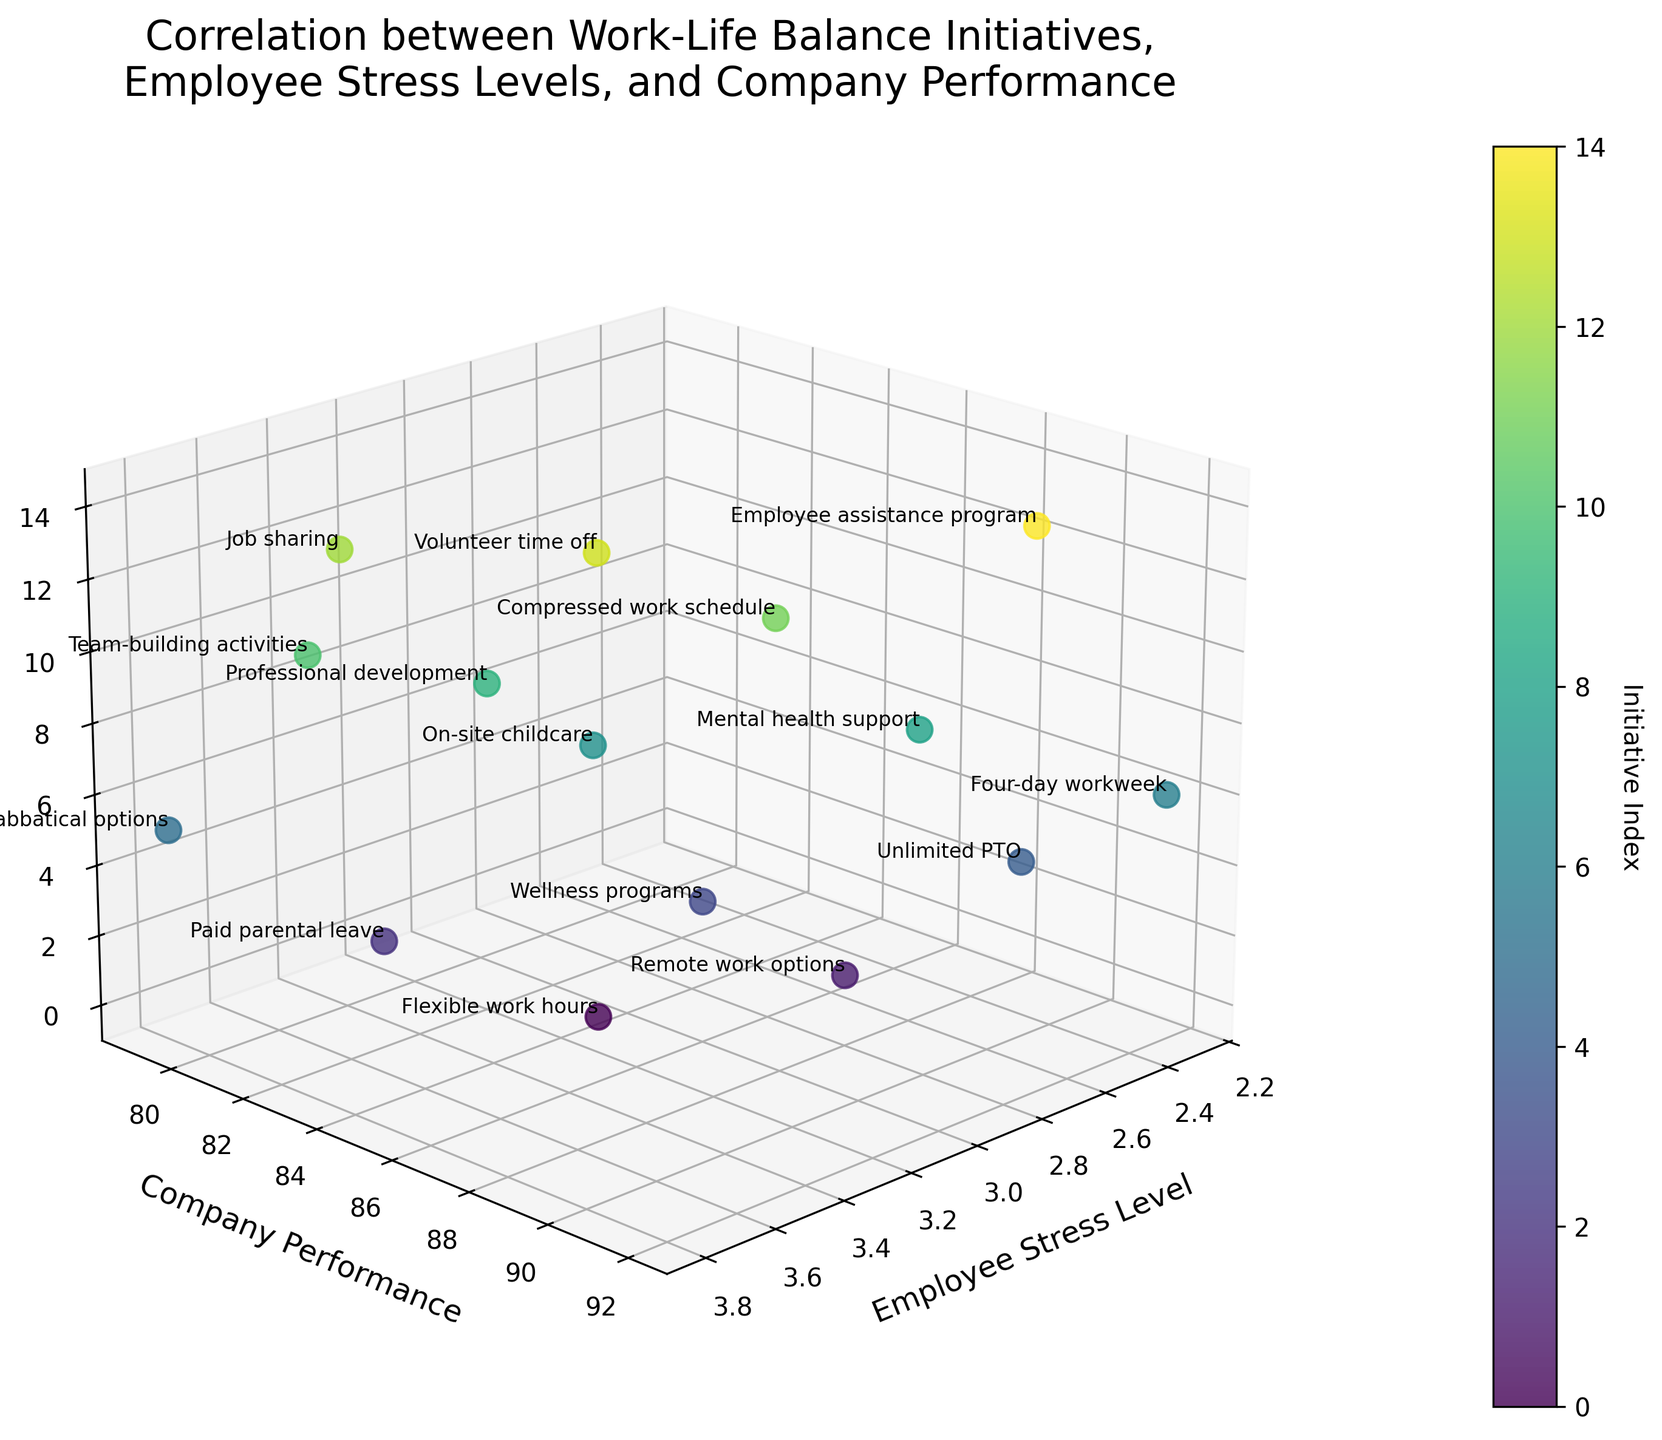What is the title of the figure? The title is normally located at the top center of the figure. It reads, "Correlation between Work-Life Balance Initiatives, Employee Stress Levels, and Company Performance".
Answer: Correlation between Work-Life Balance Initiatives, Employee Stress Levels, and Company Performance Which initiative has the lowest employee stress level? The x-axis represents the Employee Stress Level. By scanning the plot, the data point furthest left, representing the lowest stress level, corresponds to "Four-day workweek".
Answer: Four-day workweek What is the highest company performance score observed, and which initiative does it correspond to? The y-axis represents Company Performance. Identifying the highest data point on the y-axis, the label associated with it is "Four-day workweek" with a performance score of 92.
Answer: 92, Four-day workweek How many work-life balance initiatives are plotted in the graph? The plot has multiple data points each representing a work-life balance initiative. Counting these data points or labels reveals there are 15 initiatives.
Answer: 15 Which initiative has the highest employee stress level? The x-axis represents Employee Stress Level. By identifying the data point furthest to the right, it corresponds to "Sabbatical options" with a stress level of 3.8.
Answer: Sabbatical options Which two initiatives have the most similar employee stress levels, and what are those levels? Observing points close together along the x-axis, "Flexible work hours" and "Volunteer time off" both have similar stress levels of 3.2.
Answer: Flexible work hours and Volunteer time off, 3.2 Do higher employee stress levels generally correlate with better or worse company performance? Observing the slope of the data points on the plot, higher stress levels tend to align with lower performance scores, indicating a negative correlation.
Answer: Worse Which initiative has a performance score closest to 85 and what is the associated stress level? Looking at the y-axis and finding the data point closest to 85, the associated initiative is "Flexible work hours" with a stress level of 3.2.
Answer: Flexible work hours, 3.2 Compare the company performance score of "Unlimited PTO" and "Sabbatical options". Which is higher? The y-axis represents Company Performance. By comparing the two points, "Unlimited PTO" has a performance score of 90 while "Sabbatical options" has 79. Therefore, "Unlimited PTO" is higher.
Answer: Unlimited PTO Which work-life balance initiative lies closest to the median company performance score, and what is that score? The median of the company performance scores can be calculated and then matched with the closest data point on the y-axis. Sorting the scores (79, 80, 81, 82, 83, 84, 85, 85, 86, 87, 88, 89, 90, 91, 92), the median is the value at the 8th position in the sorted list, which is 85. The initiatives closest to 85 are "Flexible work hours" and "Volunteer time off".
Answer: Flexible work hours and Volunteer time off, 85 